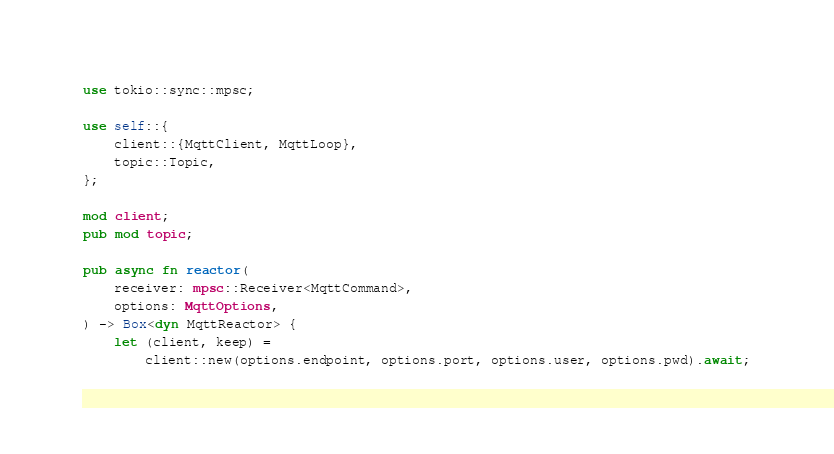<code> <loc_0><loc_0><loc_500><loc_500><_Rust_>use tokio::sync::mpsc;

use self::{
    client::{MqttClient, MqttLoop},
    topic::Topic,
};

mod client;
pub mod topic;

pub async fn reactor(
    receiver: mpsc::Receiver<MqttCommand>,
    options: MqttOptions,
) -> Box<dyn MqttReactor> {
    let (client, keep) =
        client::new(options.endpoint, options.port, options.user, options.pwd).await;</code> 